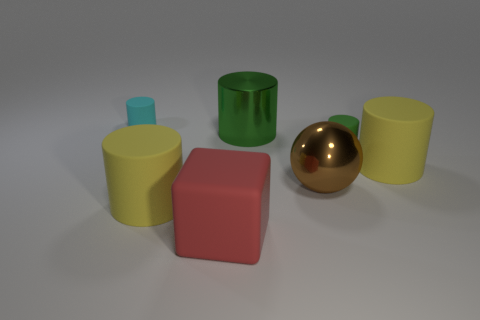Subtract 1 cylinders. How many cylinders are left? 4 Subtract all cyan cylinders. How many cylinders are left? 4 Subtract all green rubber cylinders. How many cylinders are left? 4 Subtract all blue cylinders. Subtract all brown cubes. How many cylinders are left? 5 Add 3 big green metal objects. How many objects exist? 10 Subtract all spheres. How many objects are left? 6 Subtract 0 cyan blocks. How many objects are left? 7 Subtract all small cyan balls. Subtract all large rubber cylinders. How many objects are left? 5 Add 6 matte cylinders. How many matte cylinders are left? 10 Add 7 cyan matte cylinders. How many cyan matte cylinders exist? 8 